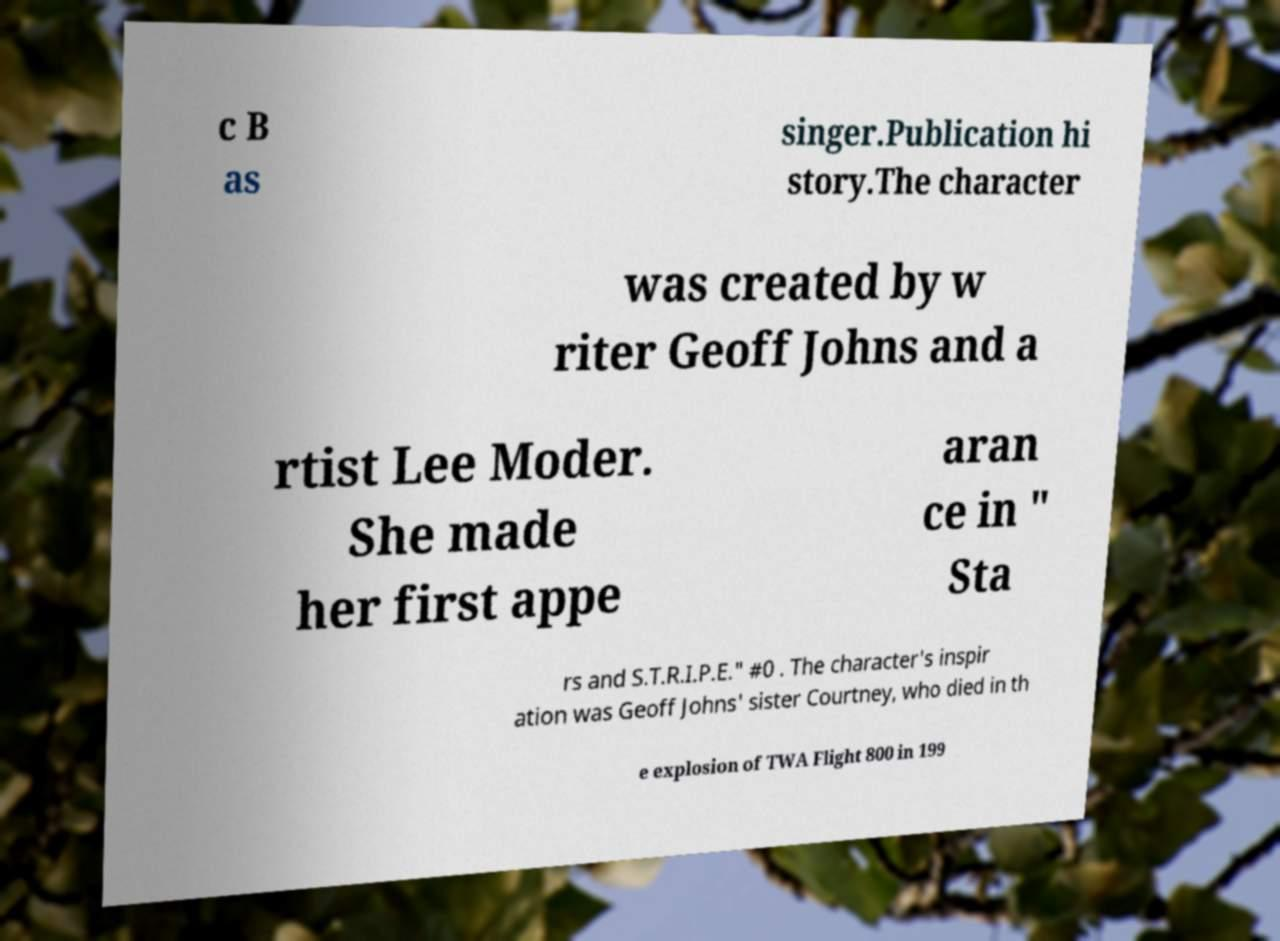Can you accurately transcribe the text from the provided image for me? c B as singer.Publication hi story.The character was created by w riter Geoff Johns and a rtist Lee Moder. She made her first appe aran ce in " Sta rs and S.T.R.I.P.E." #0 . The character's inspir ation was Geoff Johns' sister Courtney, who died in th e explosion of TWA Flight 800 in 199 